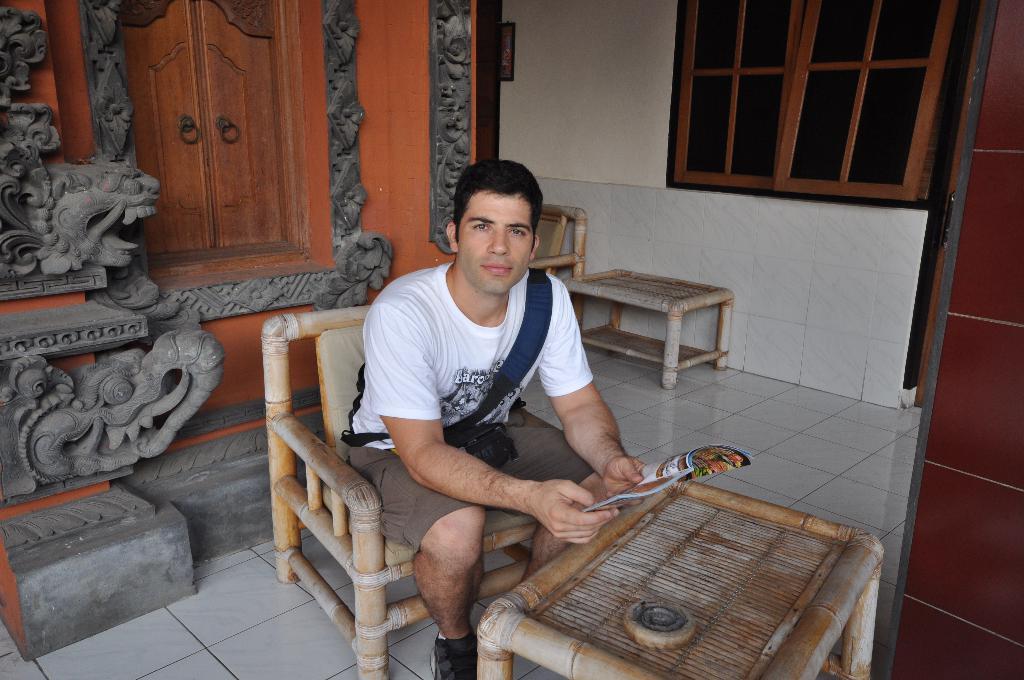Please provide a concise description of this image. In this picture there is a man who is sitting on the chair, by holding a book in his hands and there is a table at the bottom side of the image, there is a window at the top side of the life. 